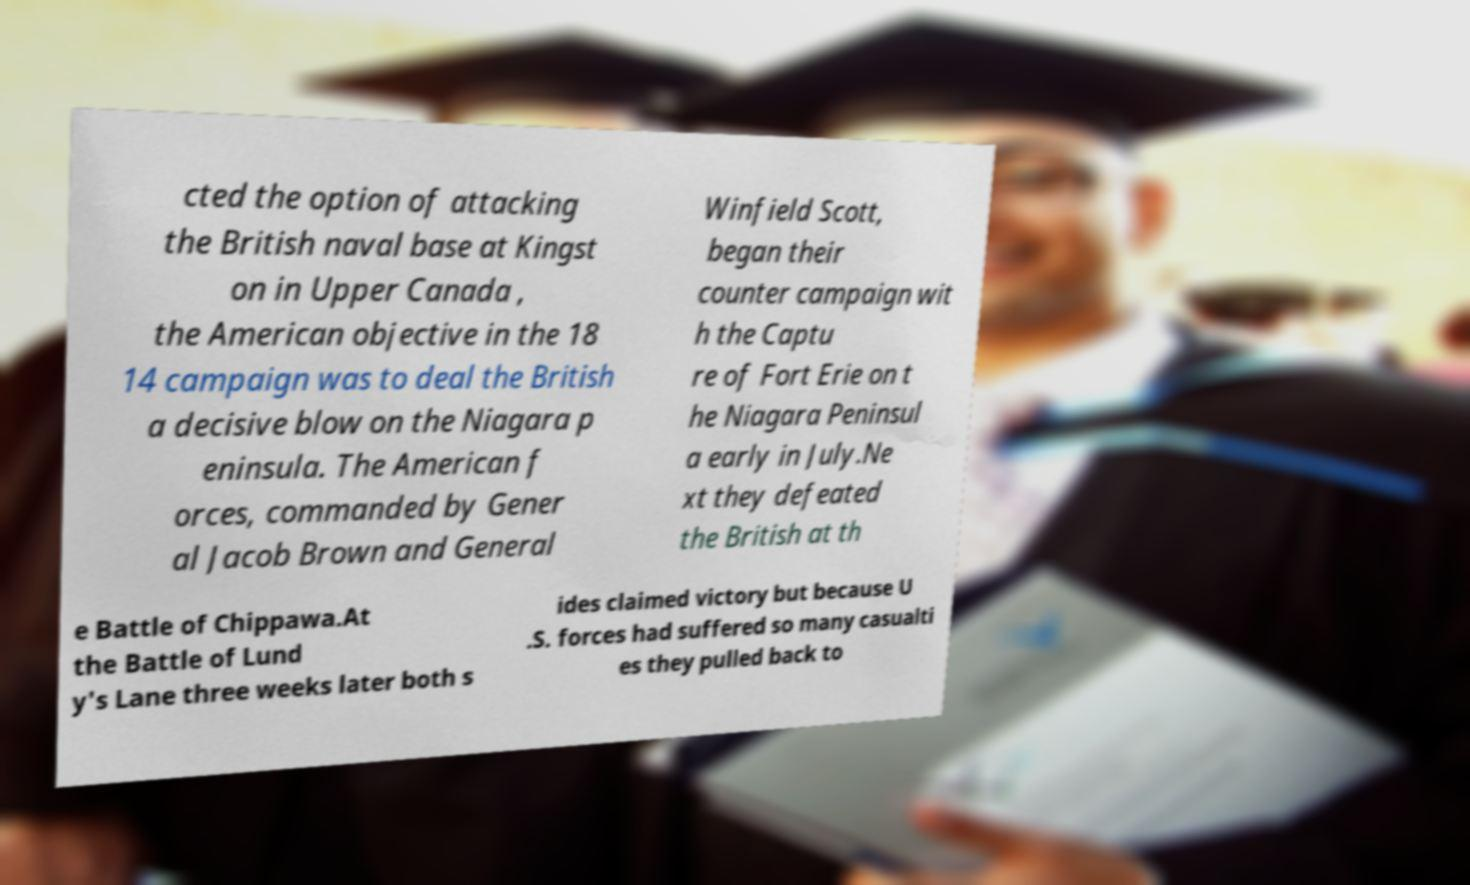Can you read and provide the text displayed in the image?This photo seems to have some interesting text. Can you extract and type it out for me? cted the option of attacking the British naval base at Kingst on in Upper Canada , the American objective in the 18 14 campaign was to deal the British a decisive blow on the Niagara p eninsula. The American f orces, commanded by Gener al Jacob Brown and General Winfield Scott, began their counter campaign wit h the Captu re of Fort Erie on t he Niagara Peninsul a early in July.Ne xt they defeated the British at th e Battle of Chippawa.At the Battle of Lund y's Lane three weeks later both s ides claimed victory but because U .S. forces had suffered so many casualti es they pulled back to 